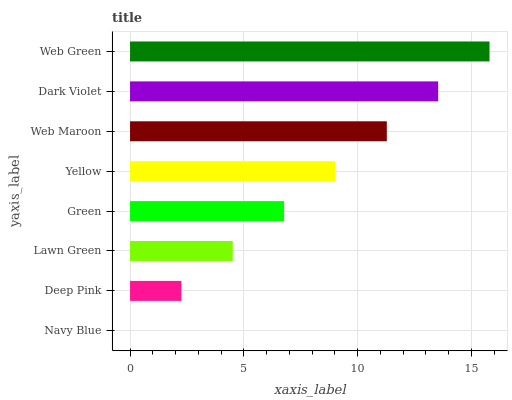Is Navy Blue the minimum?
Answer yes or no. Yes. Is Web Green the maximum?
Answer yes or no. Yes. Is Deep Pink the minimum?
Answer yes or no. No. Is Deep Pink the maximum?
Answer yes or no. No. Is Deep Pink greater than Navy Blue?
Answer yes or no. Yes. Is Navy Blue less than Deep Pink?
Answer yes or no. Yes. Is Navy Blue greater than Deep Pink?
Answer yes or no. No. Is Deep Pink less than Navy Blue?
Answer yes or no. No. Is Yellow the high median?
Answer yes or no. Yes. Is Green the low median?
Answer yes or no. Yes. Is Green the high median?
Answer yes or no. No. Is Dark Violet the low median?
Answer yes or no. No. 